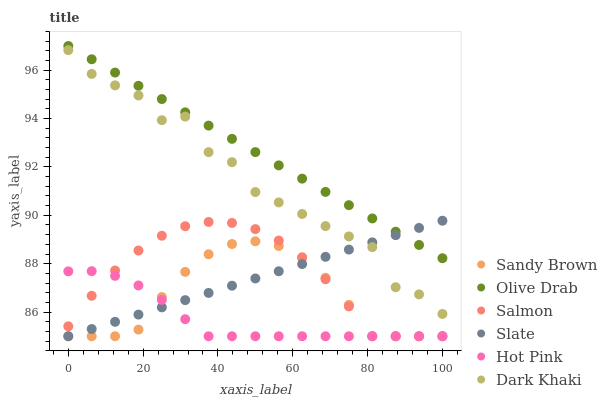Does Hot Pink have the minimum area under the curve?
Answer yes or no. Yes. Does Olive Drab have the maximum area under the curve?
Answer yes or no. Yes. Does Salmon have the minimum area under the curve?
Answer yes or no. No. Does Salmon have the maximum area under the curve?
Answer yes or no. No. Is Slate the smoothest?
Answer yes or no. Yes. Is Dark Khaki the roughest?
Answer yes or no. Yes. Is Hot Pink the smoothest?
Answer yes or no. No. Is Hot Pink the roughest?
Answer yes or no. No. Does Slate have the lowest value?
Answer yes or no. Yes. Does Dark Khaki have the lowest value?
Answer yes or no. No. Does Olive Drab have the highest value?
Answer yes or no. Yes. Does Salmon have the highest value?
Answer yes or no. No. Is Sandy Brown less than Olive Drab?
Answer yes or no. Yes. Is Olive Drab greater than Hot Pink?
Answer yes or no. Yes. Does Sandy Brown intersect Salmon?
Answer yes or no. Yes. Is Sandy Brown less than Salmon?
Answer yes or no. No. Is Sandy Brown greater than Salmon?
Answer yes or no. No. Does Sandy Brown intersect Olive Drab?
Answer yes or no. No. 